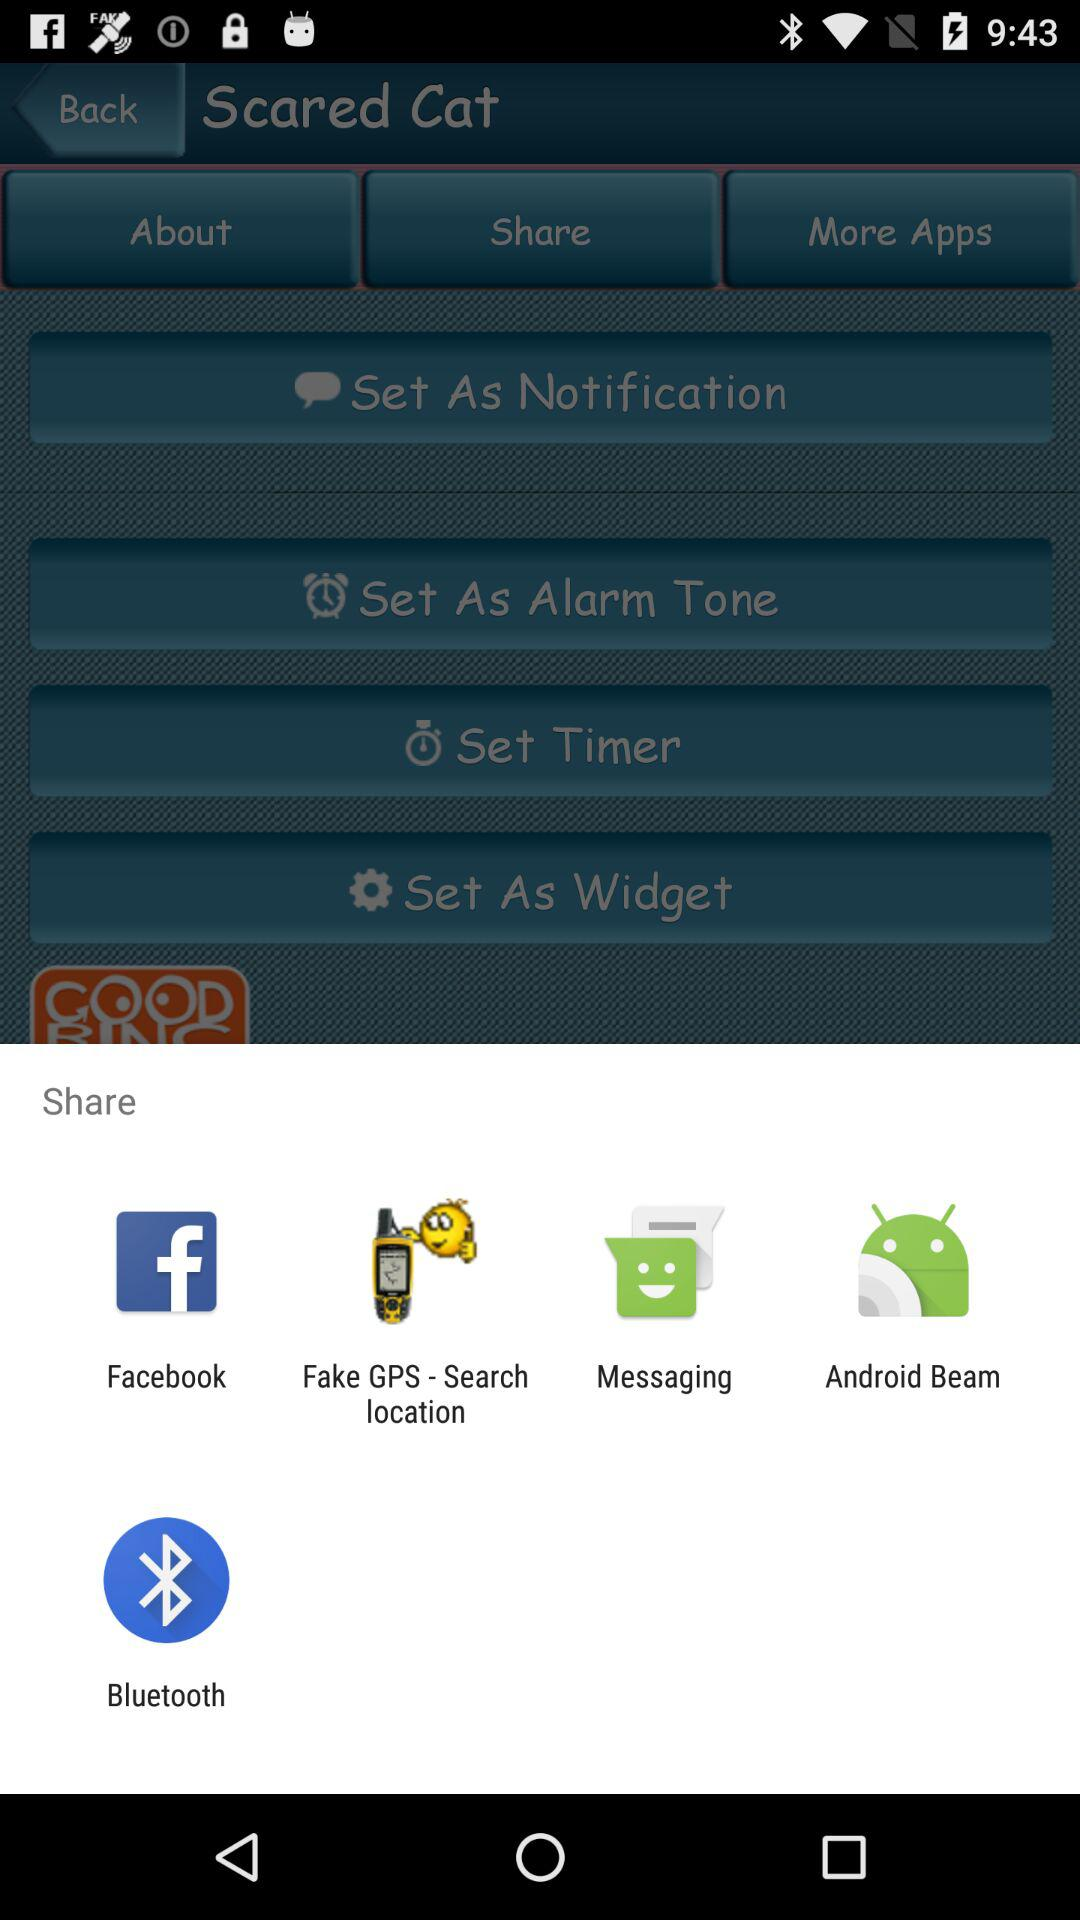Which sharing options are there? The sharing options are "Facebook", "Fake GPS - Search location", "Messaging", "Android Beam" and "Bluetooth". 